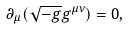Convert formula to latex. <formula><loc_0><loc_0><loc_500><loc_500>\partial _ { \mu } ( \sqrt { - g } g ^ { \mu \nu } ) = 0 ,</formula> 